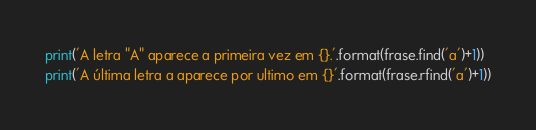<code> <loc_0><loc_0><loc_500><loc_500><_Python_>print('A letra "A" aparece a primeira vez em {}.'.format(frase.find('a')+1))
print('A última letra a aparece por ultimo em {}'.format(frase.rfind('a')+1))</code> 